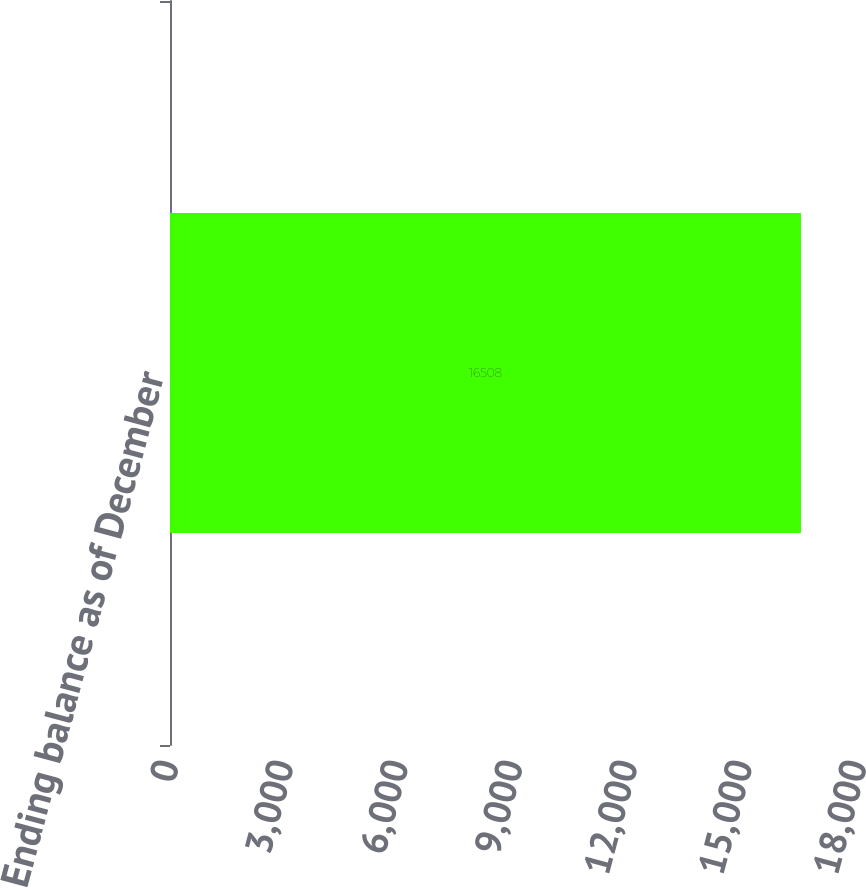<chart> <loc_0><loc_0><loc_500><loc_500><bar_chart><fcel>Ending balance as of December<nl><fcel>16508<nl></chart> 